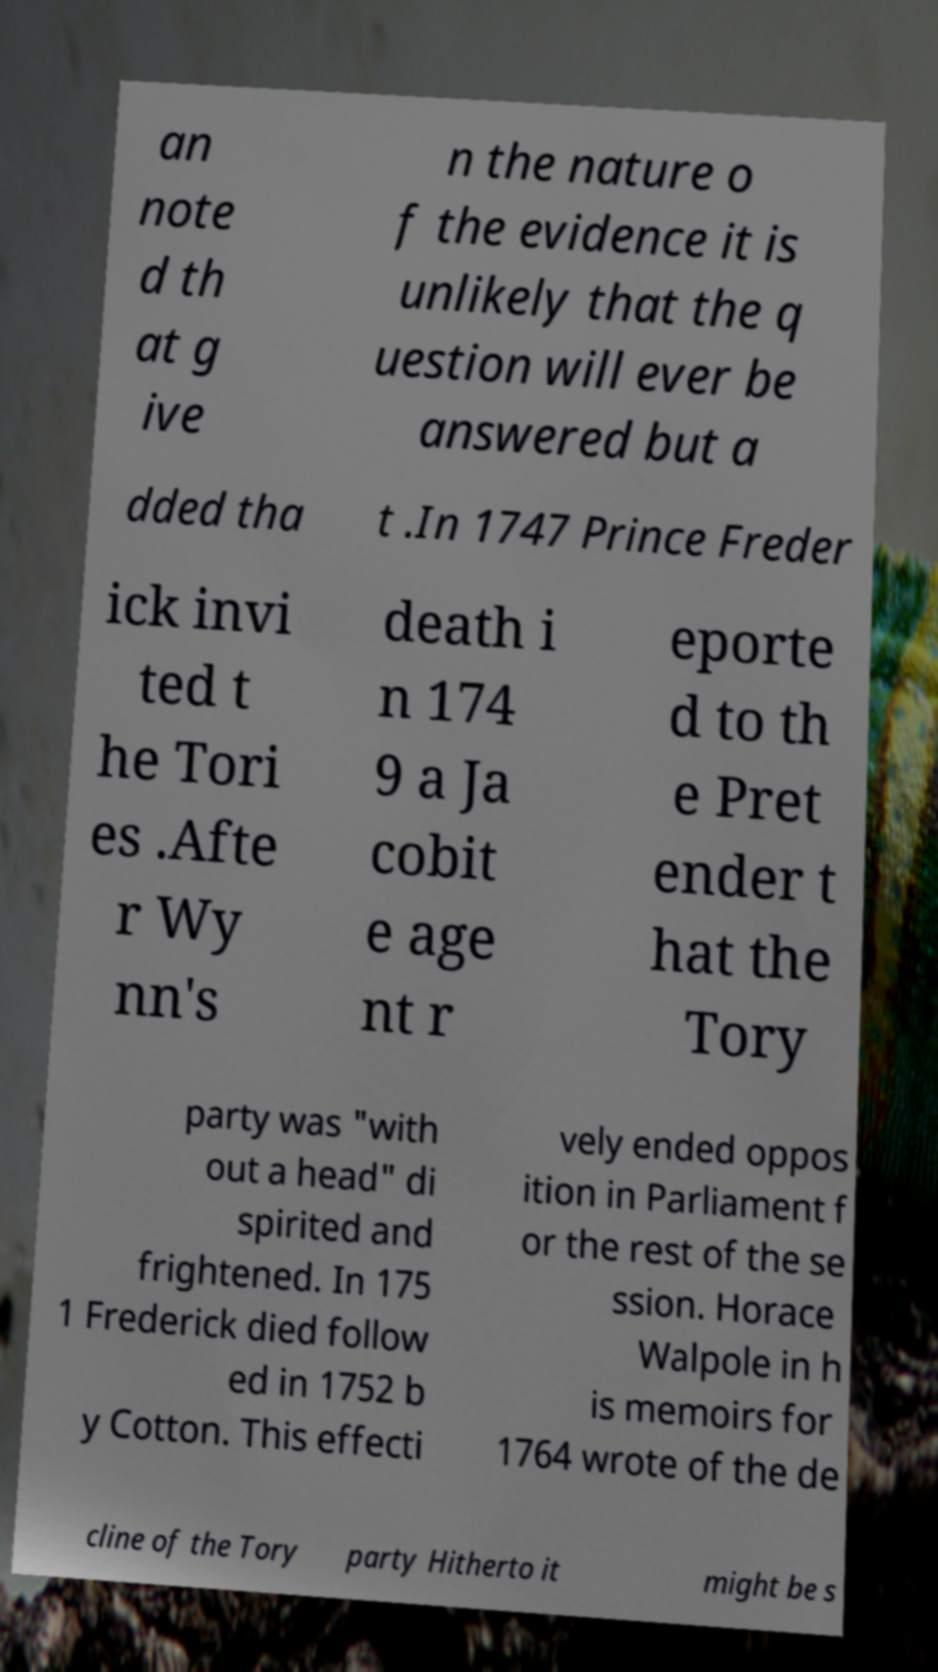I need the written content from this picture converted into text. Can you do that? an note d th at g ive n the nature o f the evidence it is unlikely that the q uestion will ever be answered but a dded tha t .In 1747 Prince Freder ick invi ted t he Tori es .Afte r Wy nn's death i n 174 9 a Ja cobit e age nt r eporte d to th e Pret ender t hat the Tory party was "with out a head" di spirited and frightened. In 175 1 Frederick died follow ed in 1752 b y Cotton. This effecti vely ended oppos ition in Parliament f or the rest of the se ssion. Horace Walpole in h is memoirs for 1764 wrote of the de cline of the Tory party Hitherto it might be s 